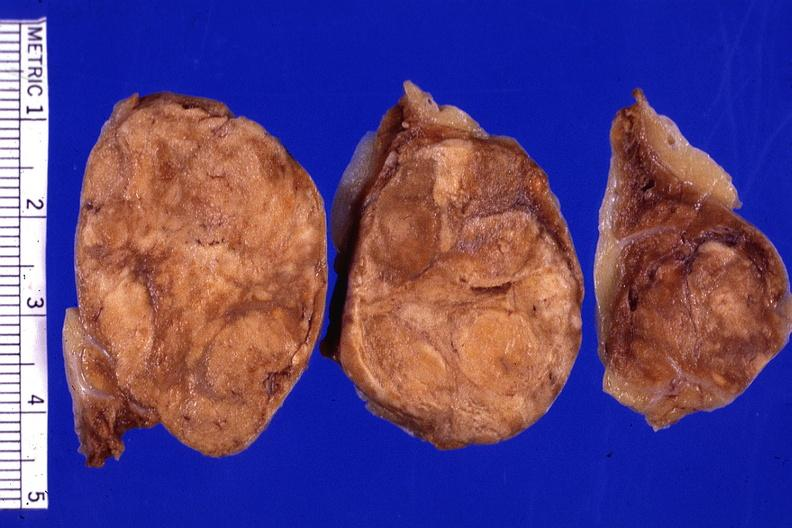what does this image show?
Answer the question using a single word or phrase. Cut surface 3 cm lesion very good 